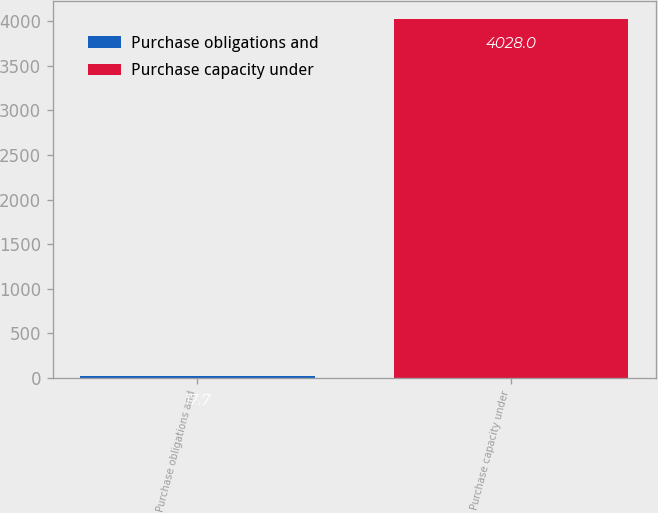Convert chart to OTSL. <chart><loc_0><loc_0><loc_500><loc_500><bar_chart><fcel>Purchase obligations and<fcel>Purchase capacity under<nl><fcel>17.7<fcel>4028<nl></chart> 